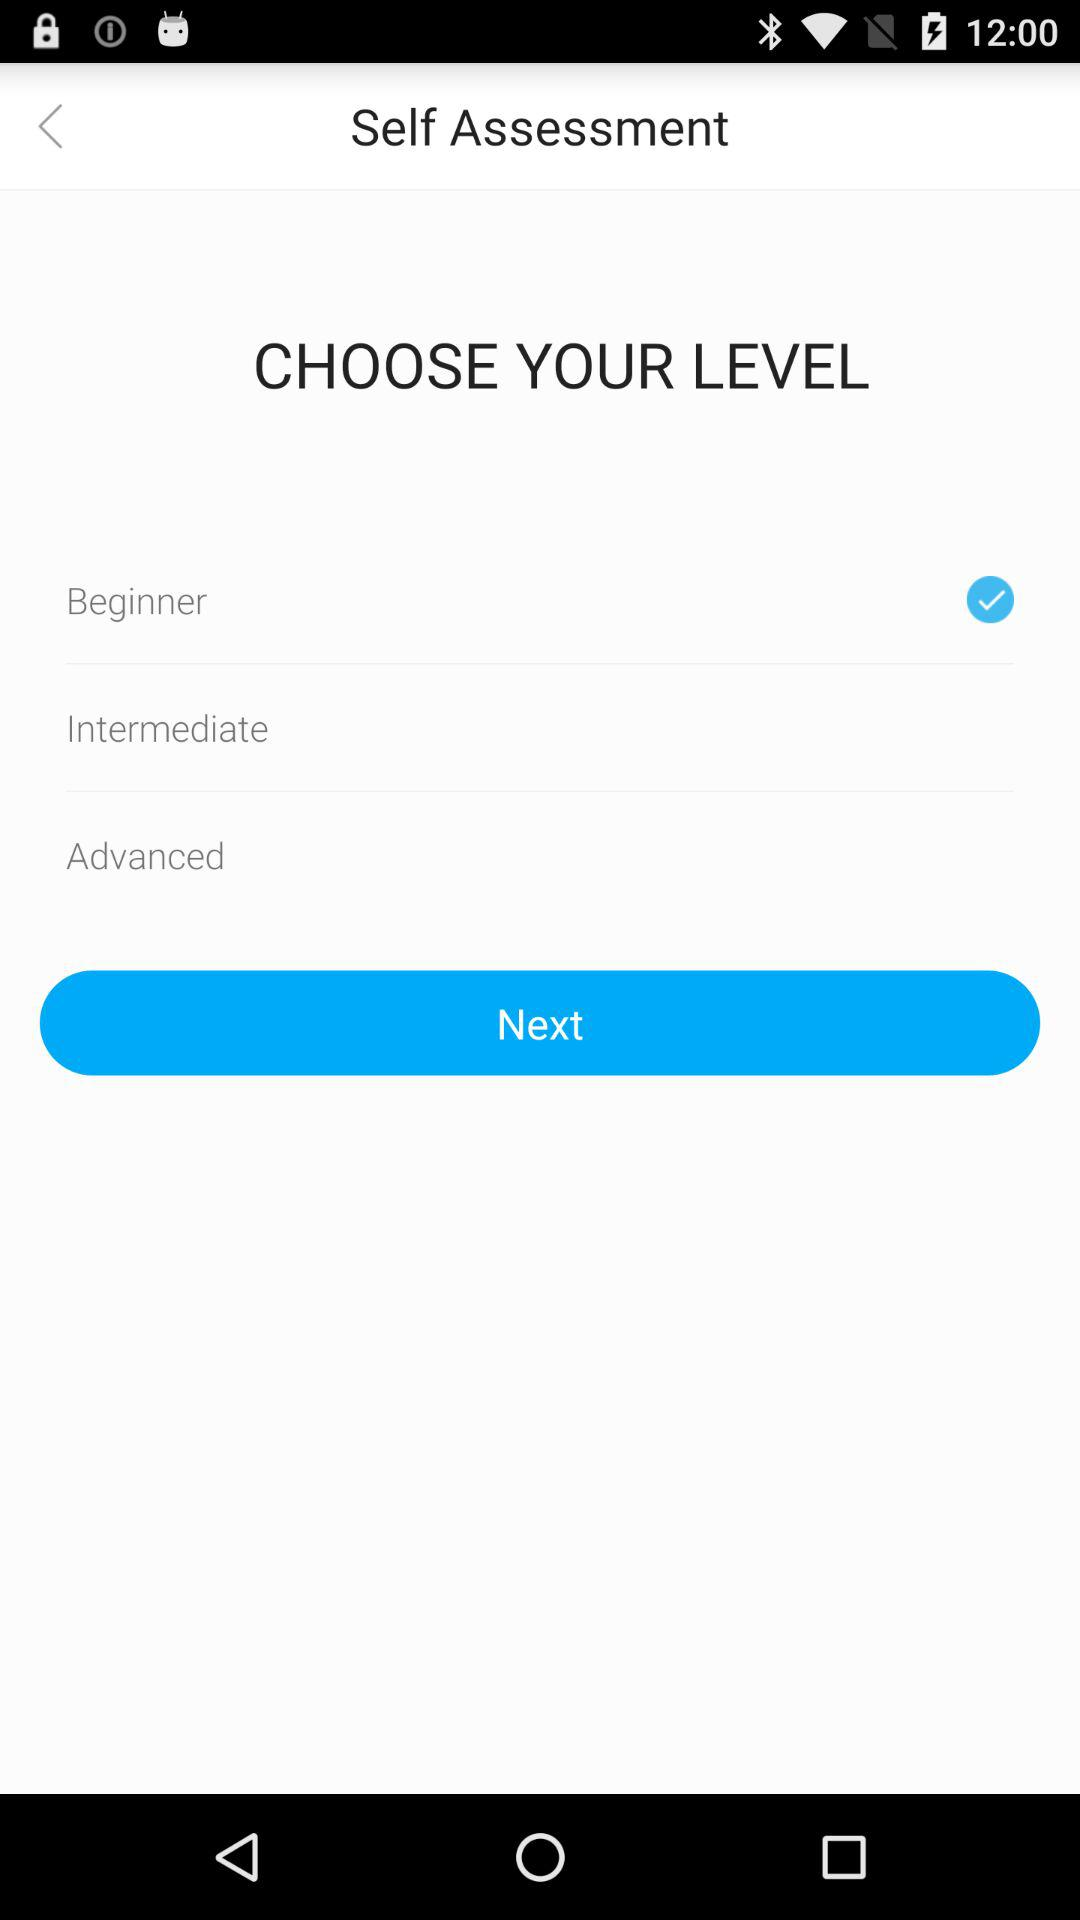How many levels are there to choose from?
Answer the question using a single word or phrase. 3 